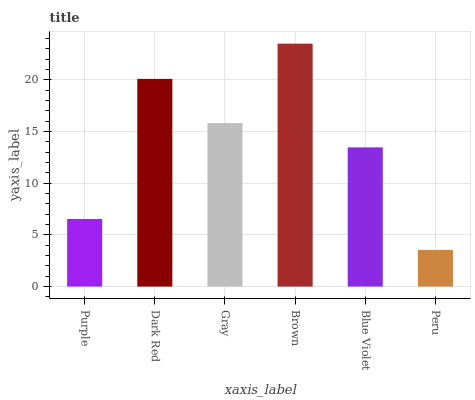Is Dark Red the minimum?
Answer yes or no. No. Is Dark Red the maximum?
Answer yes or no. No. Is Dark Red greater than Purple?
Answer yes or no. Yes. Is Purple less than Dark Red?
Answer yes or no. Yes. Is Purple greater than Dark Red?
Answer yes or no. No. Is Dark Red less than Purple?
Answer yes or no. No. Is Gray the high median?
Answer yes or no. Yes. Is Blue Violet the low median?
Answer yes or no. Yes. Is Purple the high median?
Answer yes or no. No. Is Dark Red the low median?
Answer yes or no. No. 